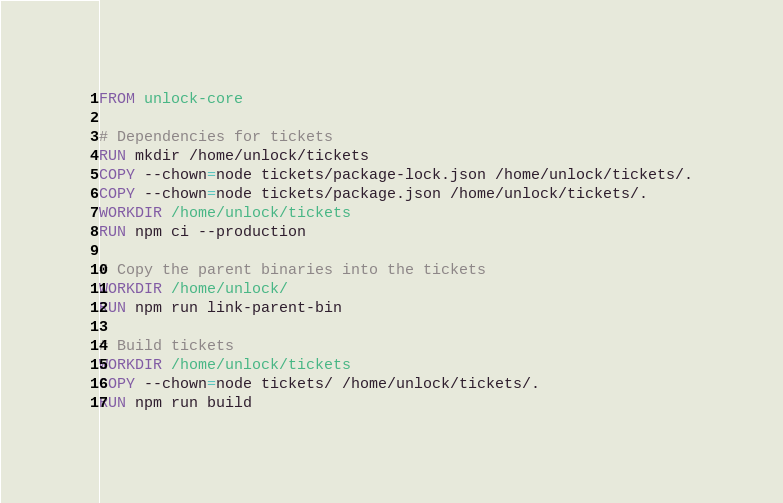Convert code to text. <code><loc_0><loc_0><loc_500><loc_500><_Dockerfile_>FROM unlock-core

# Dependencies for tickets
RUN mkdir /home/unlock/tickets
COPY --chown=node tickets/package-lock.json /home/unlock/tickets/.
COPY --chown=node tickets/package.json /home/unlock/tickets/.
WORKDIR /home/unlock/tickets
RUN npm ci --production

# Copy the parent binaries into the tickets
WORKDIR /home/unlock/
RUN npm run link-parent-bin

# Build tickets
WORKDIR /home/unlock/tickets
COPY --chown=node tickets/ /home/unlock/tickets/.
RUN npm run build</code> 